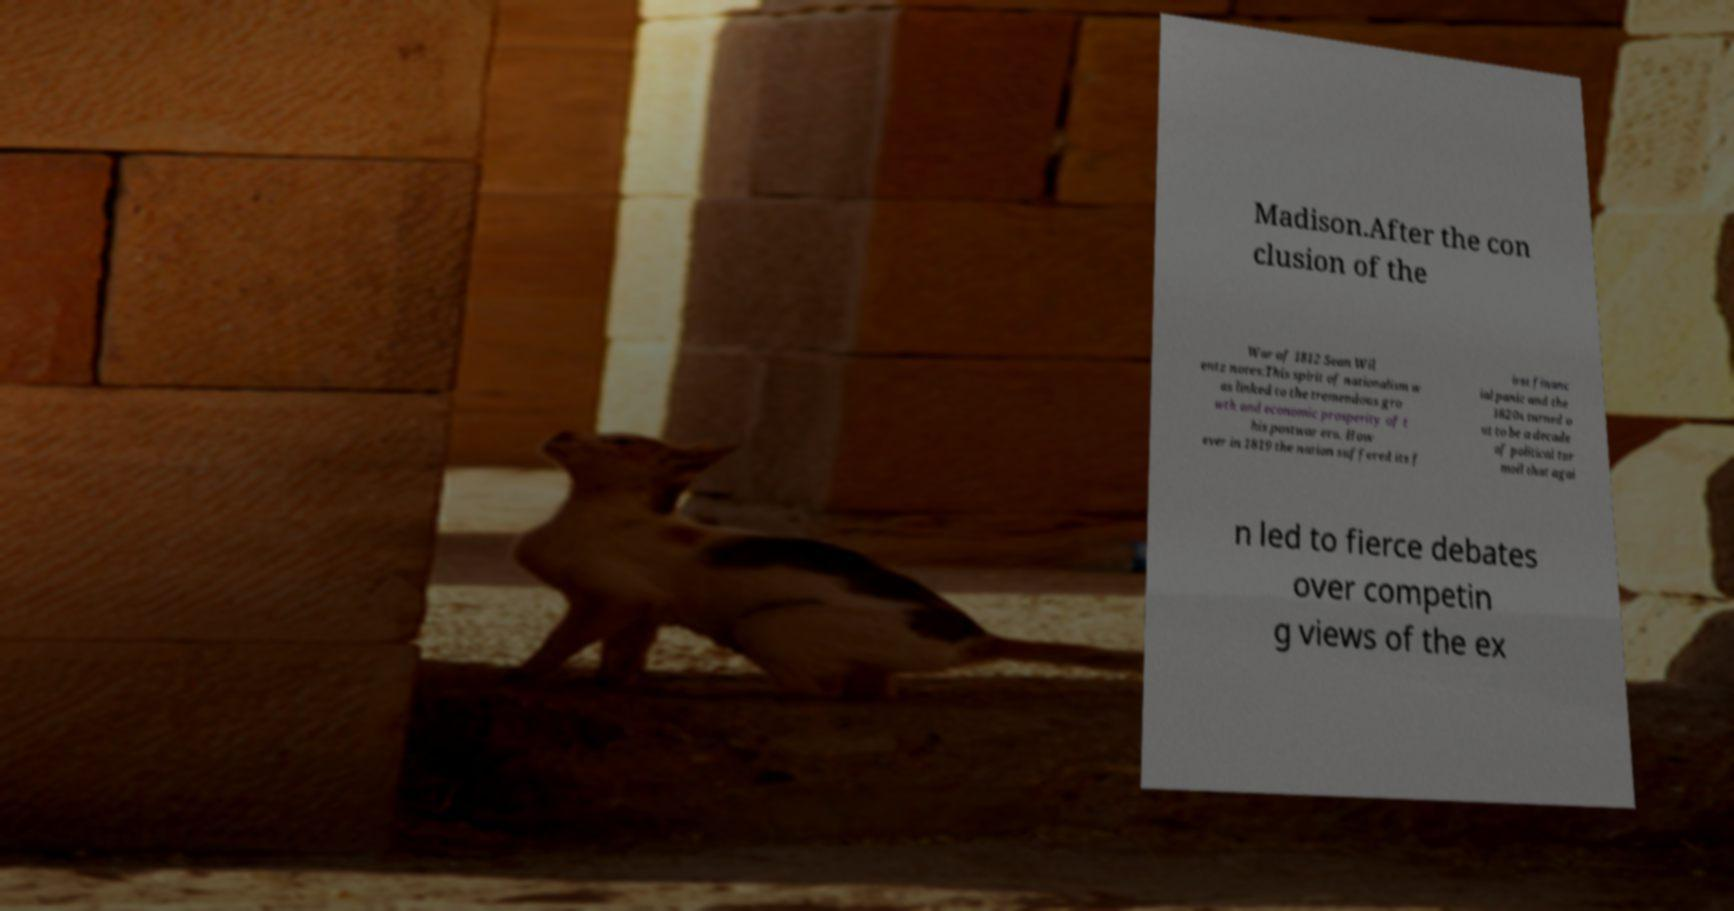What messages or text are displayed in this image? I need them in a readable, typed format. Madison.After the con clusion of the War of 1812 Sean Wil entz notes:This spirit of nationalism w as linked to the tremendous gro wth and economic prosperity of t his postwar era. How ever in 1819 the nation suffered its f irst financ ial panic and the 1820s turned o ut to be a decade of political tur moil that agai n led to fierce debates over competin g views of the ex 